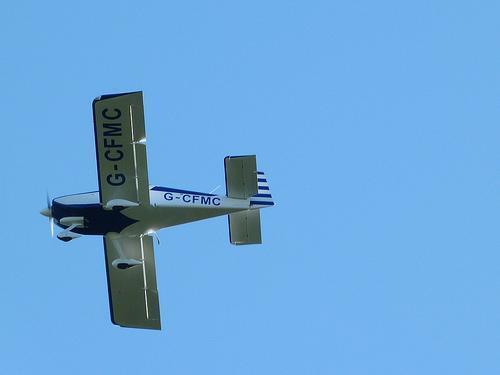How many planes are shown?
Give a very brief answer. 1. 